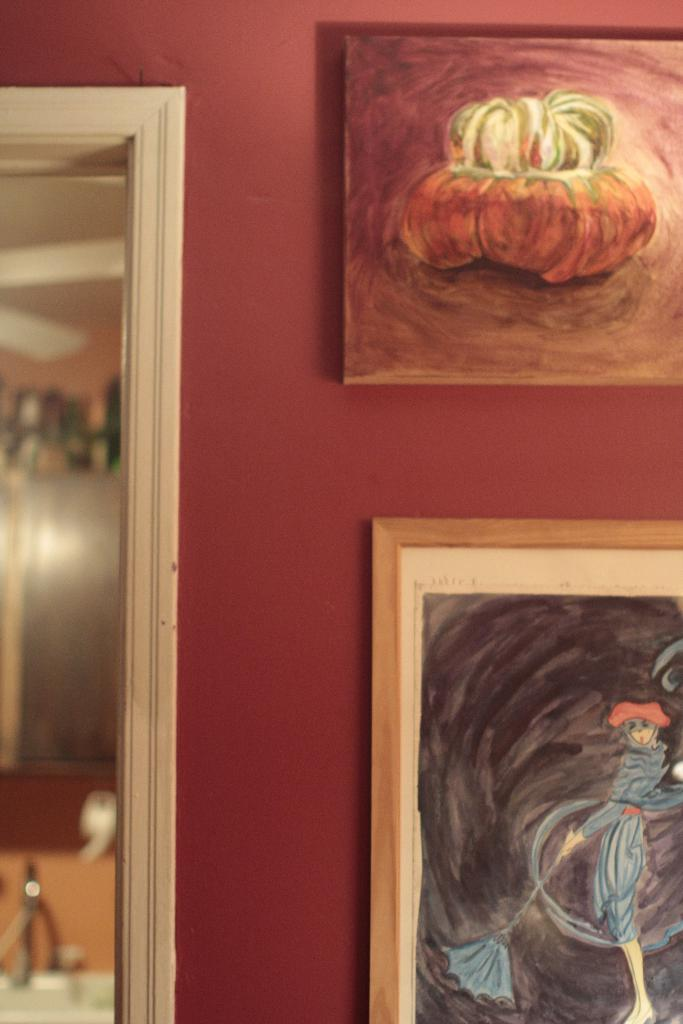What is hanging on the wall in the image? There are photos on a wall in the image. What color is the wall? The wall has a red color. Can you describe the quality of the image? The image appears to be blurred. Can you hear the bell ringing in the image? There is no bell present in the image, so it cannot be heard. Is there a yak visible in the image? There is no yak present in the image. 